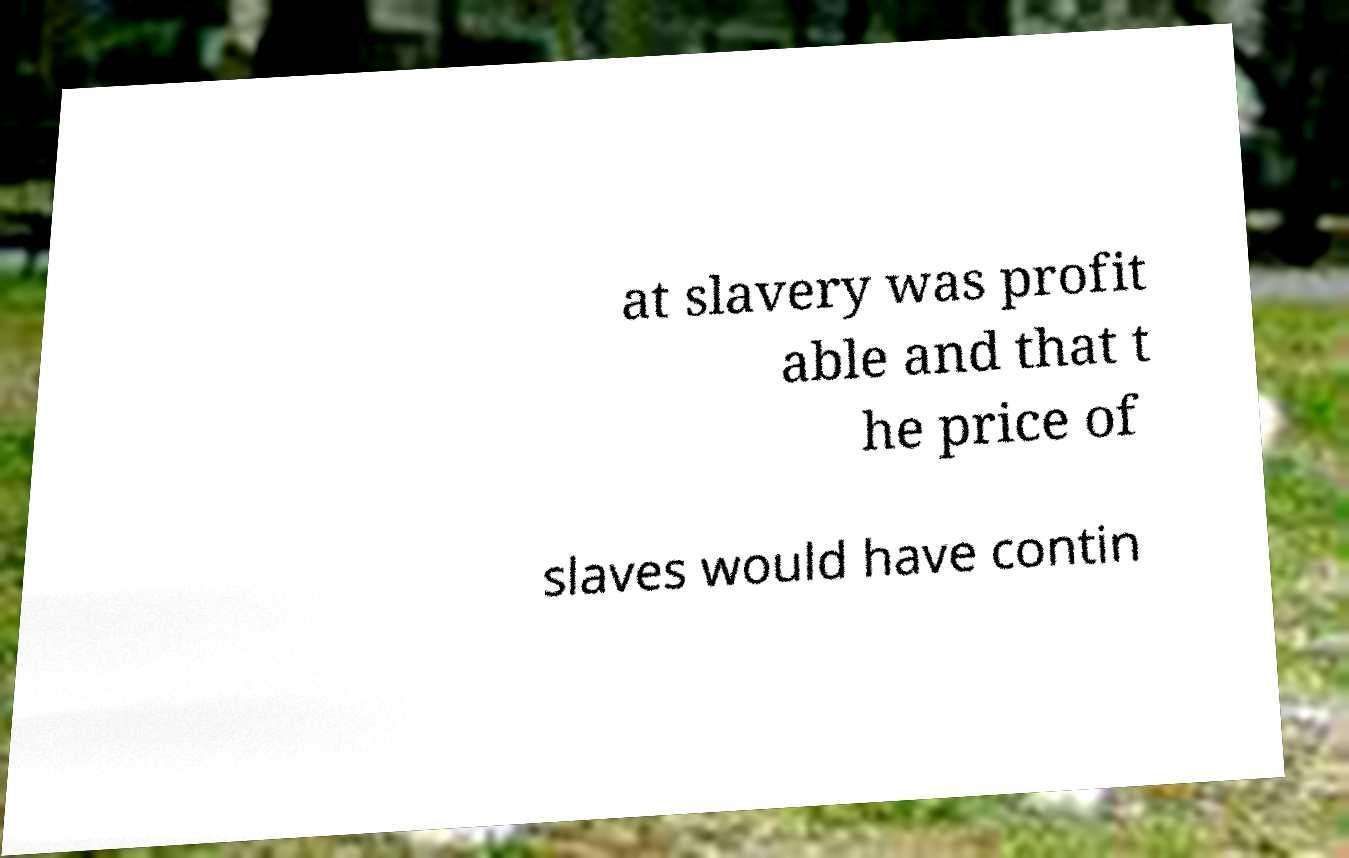Could you assist in decoding the text presented in this image and type it out clearly? at slavery was profit able and that t he price of slaves would have contin 